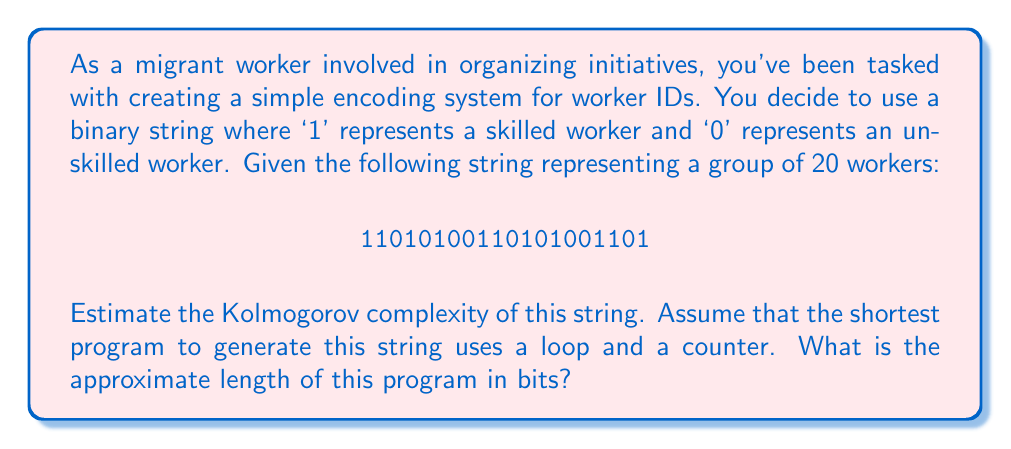Show me your answer to this math problem. To estimate the Kolmogorov complexity of the given string, we need to consider the shortest possible program that could generate this string. Let's approach this step-by-step:

1. Observe the pattern:
   The string "11010100110101001101" appears to have a repeating pattern of "1101010011".

2. Program structure:
   We can create a program that repeats this pattern twice and then adds the last digit. The program would roughly look like this in pseudocode:

   ```
   pattern = "1101010011"
   repeat pattern 2 times
   add "1" at the end
   ```

3. Estimating the bits required:
   a) To store the pattern: 10 bits
   b) To specify the number of repetitions: log₂(2) ≈ 1 bit
   c) To specify the additional digit: 1 bit
   d) Instructions for repeating and adding: ≈ 10 bits (this is a rough estimate)

4. Calculate total bits:
   Total bits ≈ 10 + 1 + 1 + 10 = 22 bits

The Kolmogorov complexity is defined as the length of the shortest program that produces the string. Our estimate of 22 bits is an upper bound, as there might be even shorter programs to generate this string.

It's important to note that this is an estimate. The actual Kolmogorov complexity is not computable in general, but we can provide upper bounds like this.
Answer: The estimated Kolmogorov complexity of the given string is approximately 22 bits. 